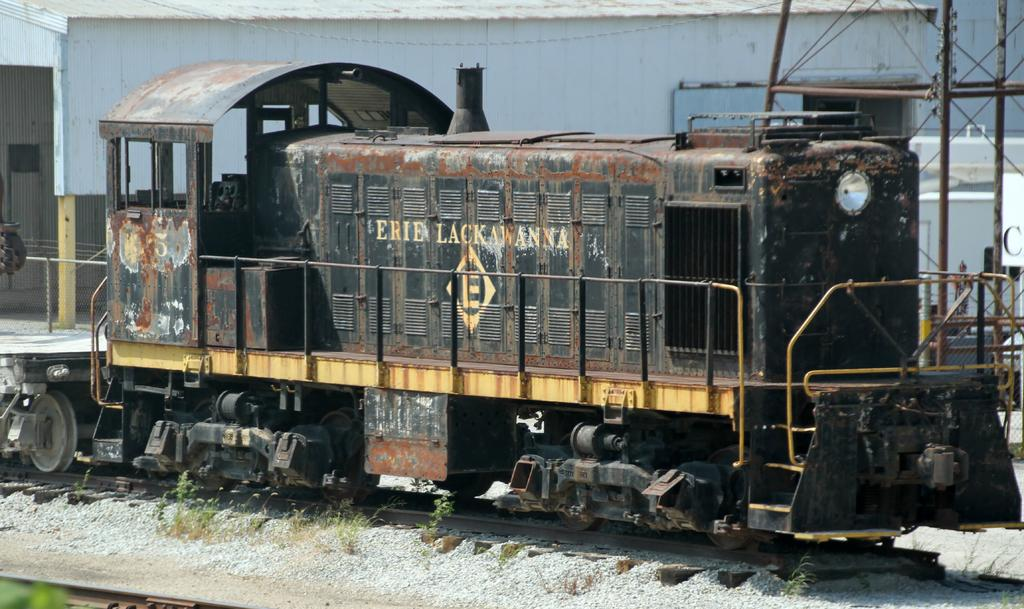What type of vehicle is in the image? There is an old and damaged train engine in the image. Where is the train engine located? The train engine is parked on the track. What can be seen in the background of the image? There is a white color shed or warehouse in the background of the image. How many pears are hanging from the train engine in the image? There are no pears present in the image; it features an old and damaged train engine parked on the track with a white color shed or warehouse in the background. 